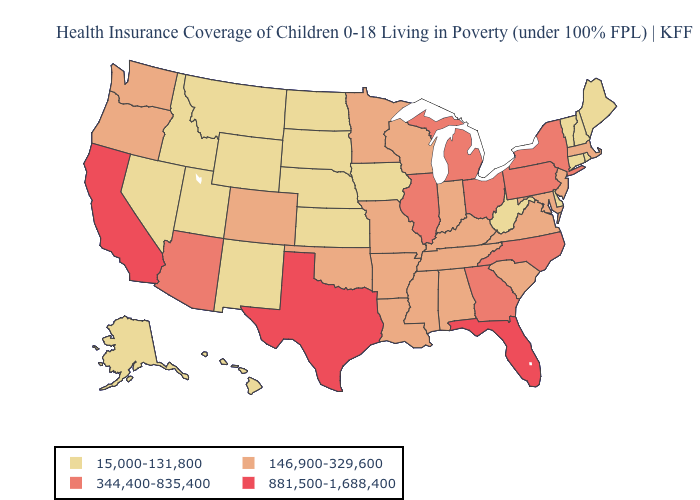Does Texas have the highest value in the South?
Answer briefly. Yes. Name the states that have a value in the range 146,900-329,600?
Answer briefly. Alabama, Arkansas, Colorado, Indiana, Kentucky, Louisiana, Maryland, Massachusetts, Minnesota, Mississippi, Missouri, New Jersey, Oklahoma, Oregon, South Carolina, Tennessee, Virginia, Washington, Wisconsin. What is the lowest value in the South?
Be succinct. 15,000-131,800. Does Kansas have the lowest value in the MidWest?
Keep it brief. Yes. What is the value of Mississippi?
Write a very short answer. 146,900-329,600. Is the legend a continuous bar?
Be succinct. No. Name the states that have a value in the range 15,000-131,800?
Concise answer only. Alaska, Connecticut, Delaware, Hawaii, Idaho, Iowa, Kansas, Maine, Montana, Nebraska, Nevada, New Hampshire, New Mexico, North Dakota, Rhode Island, South Dakota, Utah, Vermont, West Virginia, Wyoming. What is the value of Louisiana?
Quick response, please. 146,900-329,600. Name the states that have a value in the range 344,400-835,400?
Keep it brief. Arizona, Georgia, Illinois, Michigan, New York, North Carolina, Ohio, Pennsylvania. What is the highest value in the USA?
Short answer required. 881,500-1,688,400. How many symbols are there in the legend?
Give a very brief answer. 4. Name the states that have a value in the range 146,900-329,600?
Short answer required. Alabama, Arkansas, Colorado, Indiana, Kentucky, Louisiana, Maryland, Massachusetts, Minnesota, Mississippi, Missouri, New Jersey, Oklahoma, Oregon, South Carolina, Tennessee, Virginia, Washington, Wisconsin. What is the lowest value in states that border Louisiana?
Concise answer only. 146,900-329,600. Does Texas have the lowest value in the USA?
Answer briefly. No. Among the states that border New Jersey , which have the lowest value?
Quick response, please. Delaware. 